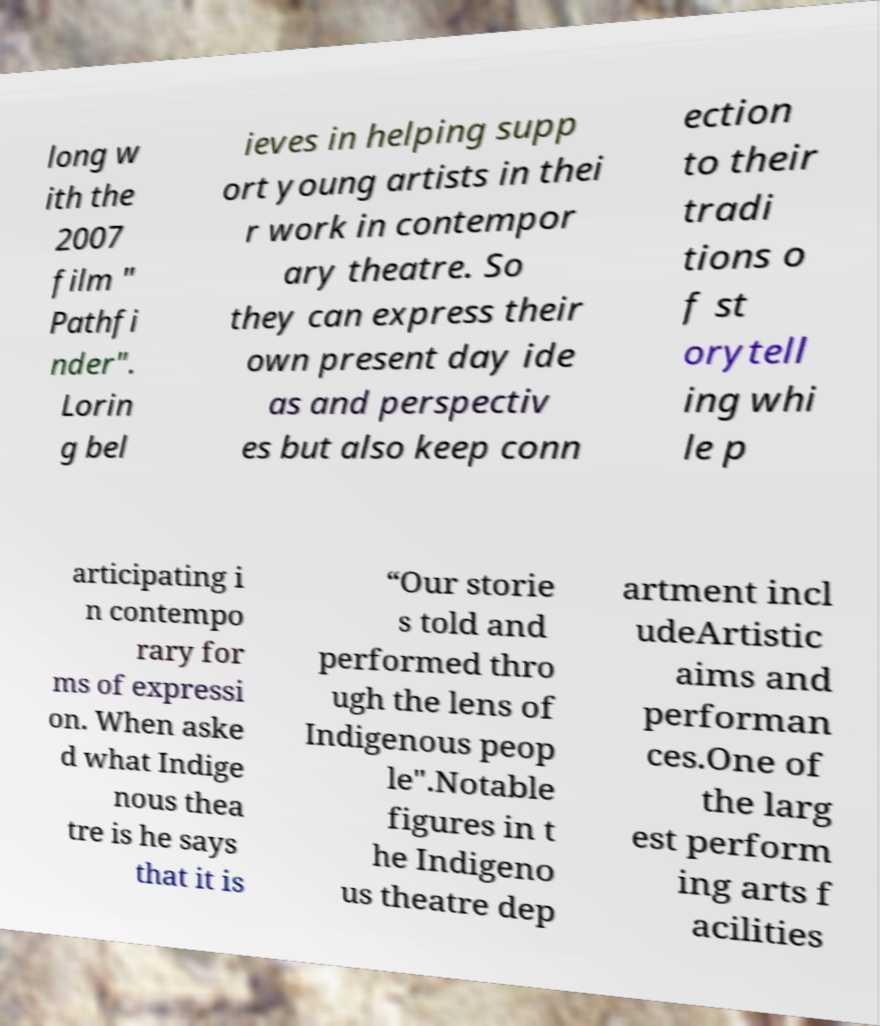Could you extract and type out the text from this image? long w ith the 2007 film " Pathfi nder". Lorin g bel ieves in helping supp ort young artists in thei r work in contempor ary theatre. So they can express their own present day ide as and perspectiv es but also keep conn ection to their tradi tions o f st orytell ing whi le p articipating i n contempo rary for ms of expressi on. When aske d what Indige nous thea tre is he says that it is “Our storie s told and performed thro ugh the lens of Indigenous peop le".Notable figures in t he Indigeno us theatre dep artment incl udeArtistic aims and performan ces.One of the larg est perform ing arts f acilities 